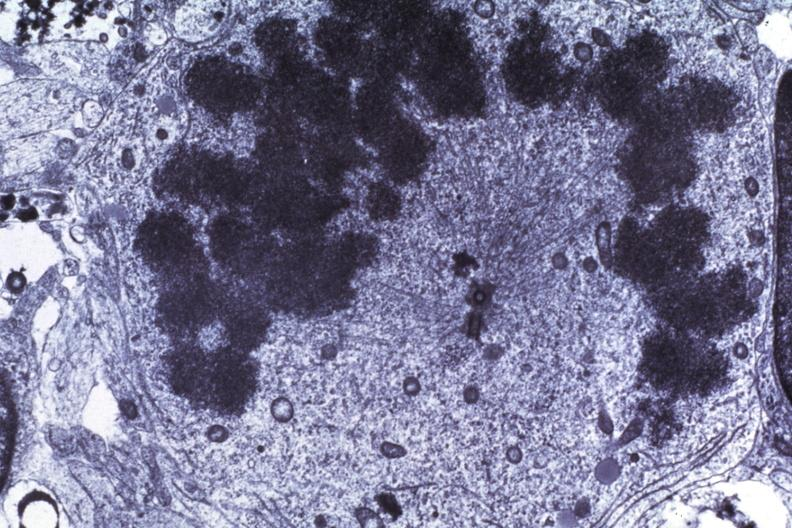what is present?
Answer the question using a single word or phrase. Medulloblastoma 